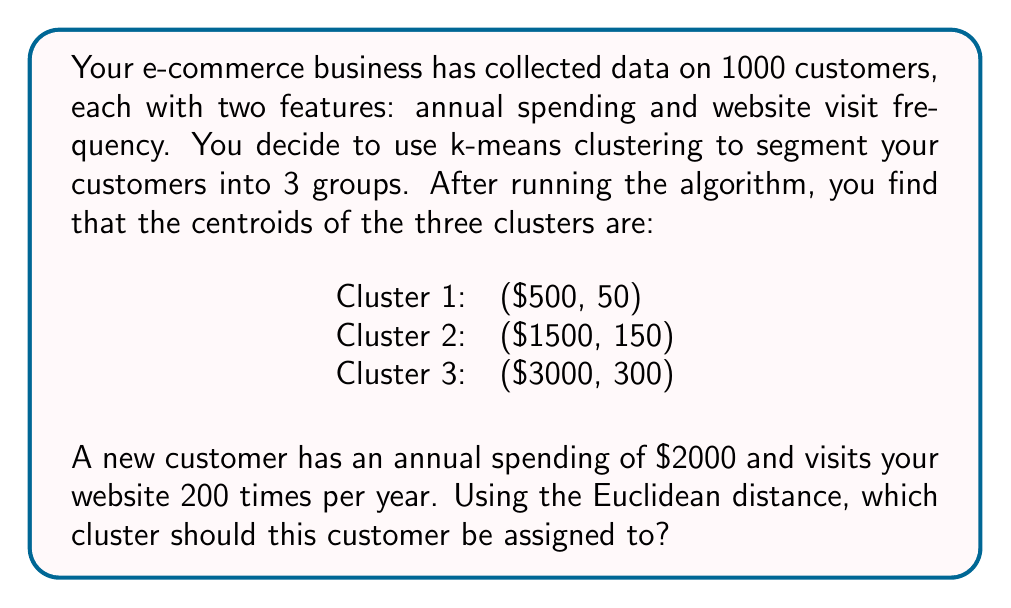Can you answer this question? To determine which cluster the new customer should be assigned to, we need to calculate the Euclidean distance between the customer's data point and each cluster centroid. The cluster with the shortest distance will be the one to which the customer is assigned.

The Euclidean distance between two points $(x_1, y_1)$ and $(x_2, y_2)$ in a 2D space is given by:

$$d = \sqrt{(x_2 - x_1)^2 + (y_2 - y_1)^2}$$

Let's calculate the distance to each cluster centroid:

1. Distance to Cluster 1 centroid:
   $$d_1 = \sqrt{(2000 - 500)^2 + (200 - 50)^2} = \sqrt{1500^2 + 150^2} = \sqrt{2,272,500} \approx 1507.48$$

2. Distance to Cluster 2 centroid:
   $$d_2 = \sqrt{(2000 - 1500)^2 + (200 - 150)^2} = \sqrt{500^2 + 50^2} = \sqrt{252,500} \approx 502.49$$

3. Distance to Cluster 3 centroid:
   $$d_3 = \sqrt{(2000 - 3000)^2 + (200 - 300)^2} = \sqrt{(-1000)^2 + (-100)^2} = \sqrt{1,010,000} \approx 1004.99$$

The shortest distance is $d_2 \approx 502.49$, which corresponds to Cluster 2.
Answer: The new customer should be assigned to Cluster 2. 